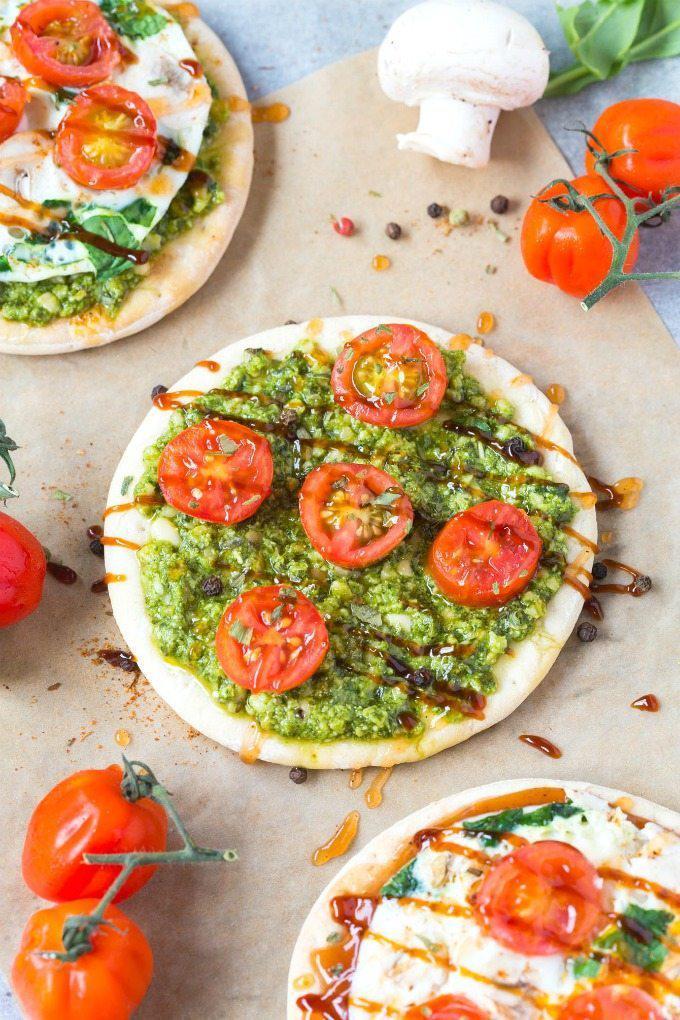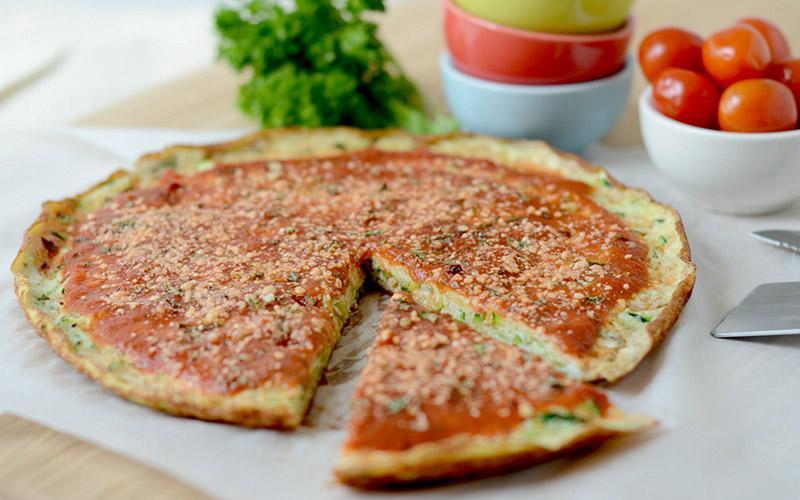The first image is the image on the left, the second image is the image on the right. For the images shown, is this caption "Fewer than two slices of pizza can be seen on a white plate." true? Answer yes or no. No. 